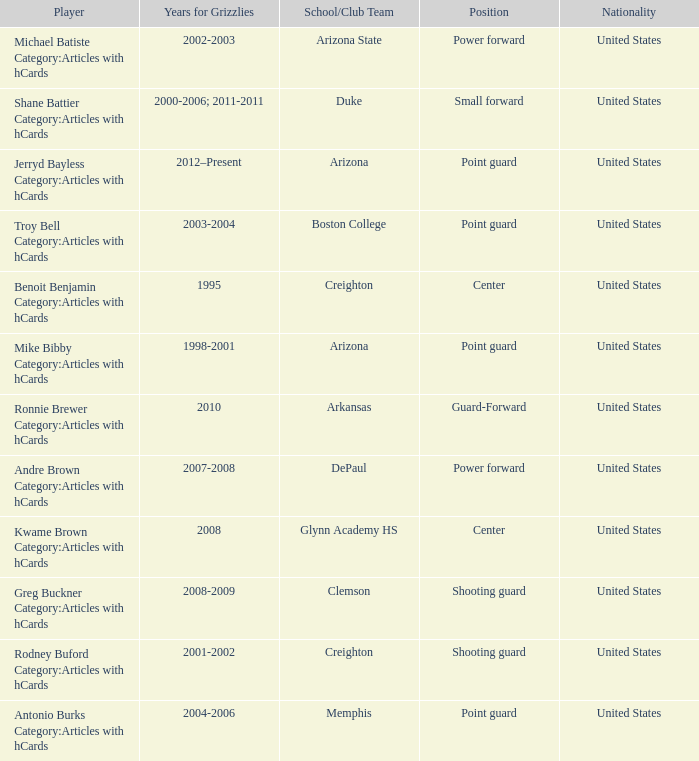Which Player has Years for Grizzlies of 2002-2003? Michael Batiste Category:Articles with hCards. 